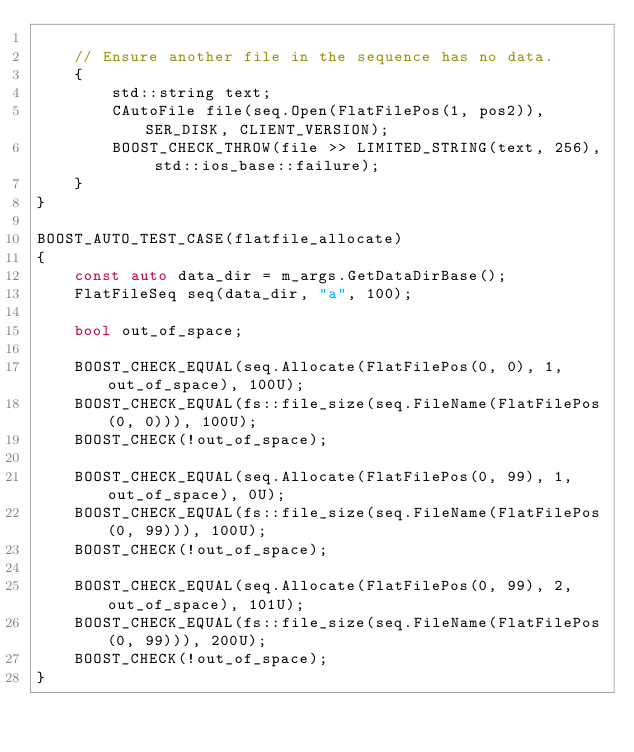<code> <loc_0><loc_0><loc_500><loc_500><_C++_>
    // Ensure another file in the sequence has no data.
    {
        std::string text;
        CAutoFile file(seq.Open(FlatFilePos(1, pos2)), SER_DISK, CLIENT_VERSION);
        BOOST_CHECK_THROW(file >> LIMITED_STRING(text, 256), std::ios_base::failure);
    }
}

BOOST_AUTO_TEST_CASE(flatfile_allocate)
{
    const auto data_dir = m_args.GetDataDirBase();
    FlatFileSeq seq(data_dir, "a", 100);

    bool out_of_space;

    BOOST_CHECK_EQUAL(seq.Allocate(FlatFilePos(0, 0), 1, out_of_space), 100U);
    BOOST_CHECK_EQUAL(fs::file_size(seq.FileName(FlatFilePos(0, 0))), 100U);
    BOOST_CHECK(!out_of_space);

    BOOST_CHECK_EQUAL(seq.Allocate(FlatFilePos(0, 99), 1, out_of_space), 0U);
    BOOST_CHECK_EQUAL(fs::file_size(seq.FileName(FlatFilePos(0, 99))), 100U);
    BOOST_CHECK(!out_of_space);

    BOOST_CHECK_EQUAL(seq.Allocate(FlatFilePos(0, 99), 2, out_of_space), 101U);
    BOOST_CHECK_EQUAL(fs::file_size(seq.FileName(FlatFilePos(0, 99))), 200U);
    BOOST_CHECK(!out_of_space);
}
</code> 